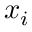<formula> <loc_0><loc_0><loc_500><loc_500>x _ { i }</formula> 